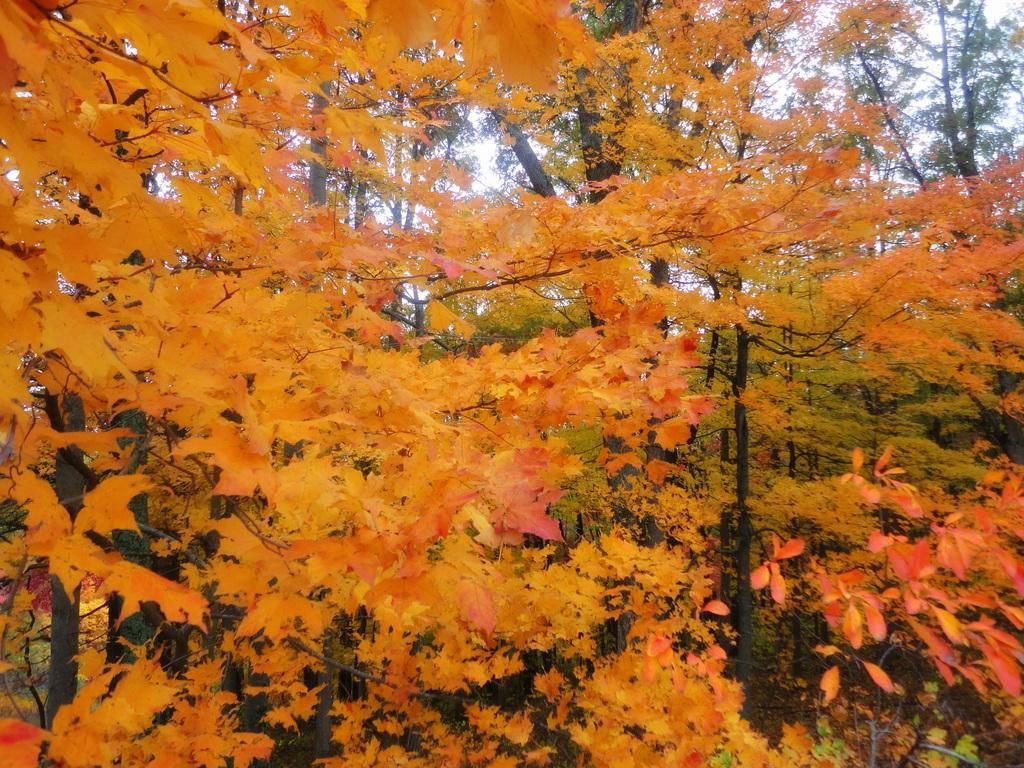In one or two sentences, can you explain what this image depicts? In the picture we can see some trees with maple leaves which are yellow, orange in color and behind it we can see some other trees and from it we can see a part of sky. 